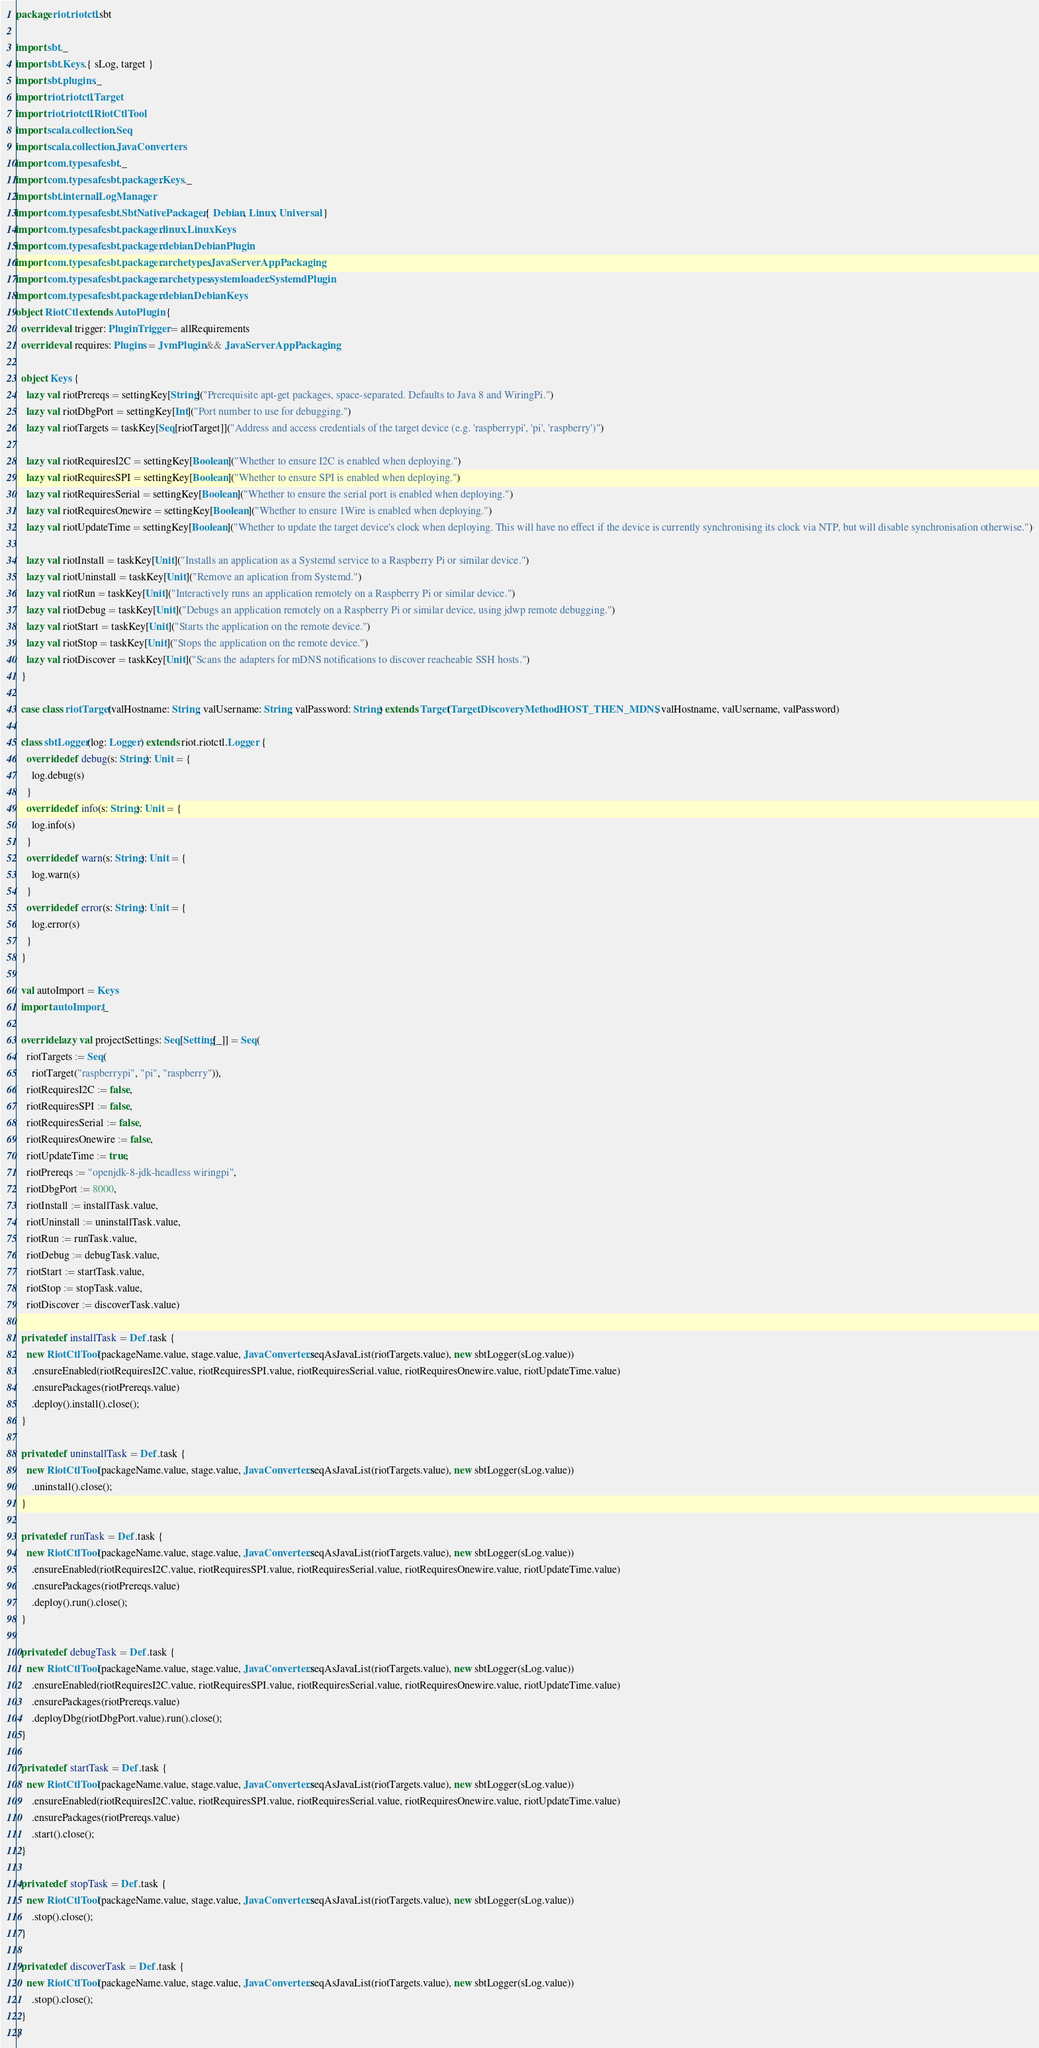<code> <loc_0><loc_0><loc_500><loc_500><_Scala_>package riot.riotctl.sbt

import sbt._
import sbt.Keys.{ sLog, target }
import sbt.plugins._
import riot.riotctl.Target
import riot.riotctl.RiotCtlTool
import scala.collection.Seq
import scala.collection.JavaConverters
import com.typesafe.sbt._
import com.typesafe.sbt.packager.Keys._
import sbt.internal.LogManager
import com.typesafe.sbt.SbtNativePackager.{ Debian, Linux, Universal }
import com.typesafe.sbt.packager.linux.LinuxKeys
import com.typesafe.sbt.packager.debian.DebianPlugin
import com.typesafe.sbt.packager.archetypes.JavaServerAppPackaging
import com.typesafe.sbt.packager.archetypes.systemloader.SystemdPlugin
import com.typesafe.sbt.packager.debian.DebianKeys
object RiotCtl extends AutoPlugin {
  override val trigger: PluginTrigger = allRequirements
  override val requires: Plugins = JvmPlugin && JavaServerAppPackaging

  object Keys {
    lazy val riotPrereqs = settingKey[String]("Prerequisite apt-get packages, space-separated. Defaults to Java 8 and WiringPi.")
    lazy val riotDbgPort = settingKey[Int]("Port number to use for debugging.")
    lazy val riotTargets = taskKey[Seq[riotTarget]]("Address and access credentials of the target device (e.g. 'raspberrypi', 'pi', 'raspberry')")

    lazy val riotRequiresI2C = settingKey[Boolean]("Whether to ensure I2C is enabled when deploying.")
    lazy val riotRequiresSPI = settingKey[Boolean]("Whether to ensure SPI is enabled when deploying.")
    lazy val riotRequiresSerial = settingKey[Boolean]("Whether to ensure the serial port is enabled when deploying.")
    lazy val riotRequiresOnewire = settingKey[Boolean]("Whether to ensure 1Wire is enabled when deploying.")
    lazy val riotUpdateTime = settingKey[Boolean]("Whether to update the target device's clock when deploying. This will have no effect if the device is currently synchronising its clock via NTP, but will disable synchronisation otherwise.")

    lazy val riotInstall = taskKey[Unit]("Installs an application as a Systemd service to a Raspberry Pi or similar device.")
    lazy val riotUninstall = taskKey[Unit]("Remove an aplication from Systemd.")
    lazy val riotRun = taskKey[Unit]("Interactively runs an application remotely on a Raspberry Pi or similar device.")
    lazy val riotDebug = taskKey[Unit]("Debugs an application remotely on a Raspberry Pi or similar device, using jdwp remote debugging.")
    lazy val riotStart = taskKey[Unit]("Starts the application on the remote device.")
    lazy val riotStop = taskKey[Unit]("Stops the application on the remote device.")
    lazy val riotDiscover = taskKey[Unit]("Scans the adapters for mDNS notifications to discover reacheable SSH hosts.")
  }

  case class riotTarget(valHostname: String, valUsername: String, valPassword: String) extends Target(Target.DiscoveryMethod.HOST_THEN_MDNS, valHostname, valUsername, valPassword)

  class sbtLogger(log: Logger) extends riot.riotctl.Logger {
    override def debug(s: String): Unit = {
      log.debug(s)
    }
    override def info(s: String): Unit = {
      log.info(s)
    }
    override def warn(s: String): Unit = {
      log.warn(s)
    }
    override def error(s: String): Unit = {
      log.error(s)
    }
  }

  val autoImport = Keys
  import autoImport._

  override lazy val projectSettings: Seq[Setting[_]] = Seq(
    riotTargets := Seq(
      riotTarget("raspberrypi", "pi", "raspberry")),
    riotRequiresI2C := false,
    riotRequiresSPI := false,
    riotRequiresSerial := false,
    riotRequiresOnewire := false,
    riotUpdateTime := true,
    riotPrereqs := "openjdk-8-jdk-headless wiringpi",
    riotDbgPort := 8000,
    riotInstall := installTask.value,
    riotUninstall := uninstallTask.value,
    riotRun := runTask.value,
    riotDebug := debugTask.value,
    riotStart := startTask.value,
    riotStop := stopTask.value,
    riotDiscover := discoverTask.value)

  private def installTask = Def.task {
    new RiotCtlTool(packageName.value, stage.value, JavaConverters.seqAsJavaList(riotTargets.value), new sbtLogger(sLog.value))
      .ensureEnabled(riotRequiresI2C.value, riotRequiresSPI.value, riotRequiresSerial.value, riotRequiresOnewire.value, riotUpdateTime.value)
      .ensurePackages(riotPrereqs.value)
      .deploy().install().close();
  }

  private def uninstallTask = Def.task {
    new RiotCtlTool(packageName.value, stage.value, JavaConverters.seqAsJavaList(riotTargets.value), new sbtLogger(sLog.value))
      .uninstall().close();
  }

  private def runTask = Def.task {
    new RiotCtlTool(packageName.value, stage.value, JavaConverters.seqAsJavaList(riotTargets.value), new sbtLogger(sLog.value))
      .ensureEnabled(riotRequiresI2C.value, riotRequiresSPI.value, riotRequiresSerial.value, riotRequiresOnewire.value, riotUpdateTime.value)
      .ensurePackages(riotPrereqs.value)
      .deploy().run().close();
  }

  private def debugTask = Def.task {
    new RiotCtlTool(packageName.value, stage.value, JavaConverters.seqAsJavaList(riotTargets.value), new sbtLogger(sLog.value))
      .ensureEnabled(riotRequiresI2C.value, riotRequiresSPI.value, riotRequiresSerial.value, riotRequiresOnewire.value, riotUpdateTime.value)
      .ensurePackages(riotPrereqs.value)
      .deployDbg(riotDbgPort.value).run().close();
  }

  private def startTask = Def.task {
    new RiotCtlTool(packageName.value, stage.value, JavaConverters.seqAsJavaList(riotTargets.value), new sbtLogger(sLog.value))
      .ensureEnabled(riotRequiresI2C.value, riotRequiresSPI.value, riotRequiresSerial.value, riotRequiresOnewire.value, riotUpdateTime.value)
      .ensurePackages(riotPrereqs.value)
      .start().close();
  }

  private def stopTask = Def.task {
    new RiotCtlTool(packageName.value, stage.value, JavaConverters.seqAsJavaList(riotTargets.value), new sbtLogger(sLog.value))
      .stop().close();
  }

  private def discoverTask = Def.task {
    new RiotCtlTool(packageName.value, stage.value, JavaConverters.seqAsJavaList(riotTargets.value), new sbtLogger(sLog.value))
      .stop().close();
  }
}
</code> 